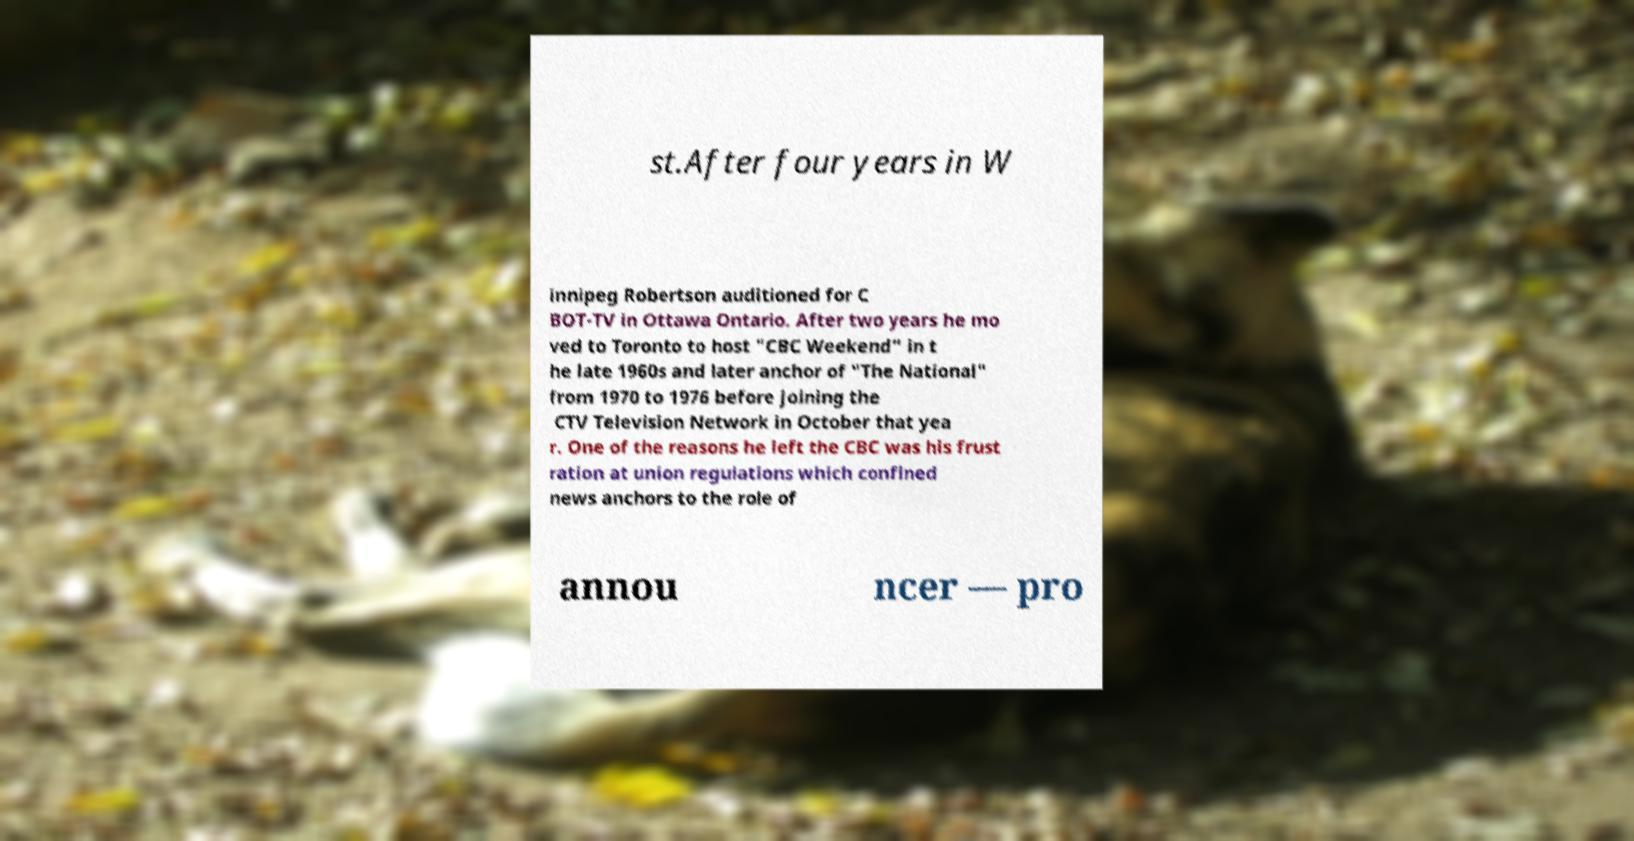Can you accurately transcribe the text from the provided image for me? st.After four years in W innipeg Robertson auditioned for C BOT-TV in Ottawa Ontario. After two years he mo ved to Toronto to host "CBC Weekend" in t he late 1960s and later anchor of "The National" from 1970 to 1976 before joining the CTV Television Network in October that yea r. One of the reasons he left the CBC was his frust ration at union regulations which confined news anchors to the role of annou ncer — pro 